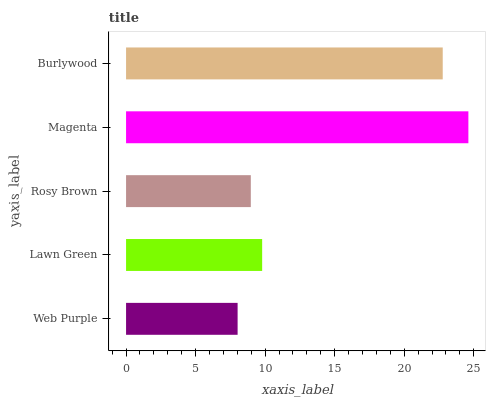Is Web Purple the minimum?
Answer yes or no. Yes. Is Magenta the maximum?
Answer yes or no. Yes. Is Lawn Green the minimum?
Answer yes or no. No. Is Lawn Green the maximum?
Answer yes or no. No. Is Lawn Green greater than Web Purple?
Answer yes or no. Yes. Is Web Purple less than Lawn Green?
Answer yes or no. Yes. Is Web Purple greater than Lawn Green?
Answer yes or no. No. Is Lawn Green less than Web Purple?
Answer yes or no. No. Is Lawn Green the high median?
Answer yes or no. Yes. Is Lawn Green the low median?
Answer yes or no. Yes. Is Web Purple the high median?
Answer yes or no. No. Is Web Purple the low median?
Answer yes or no. No. 